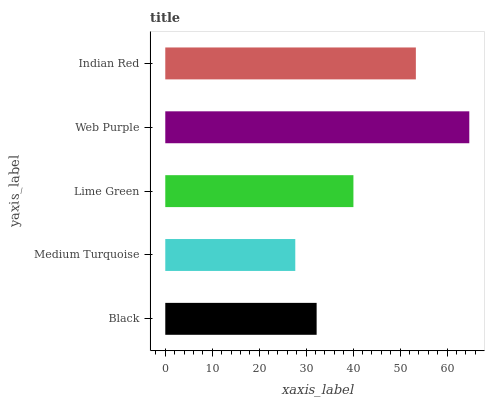Is Medium Turquoise the minimum?
Answer yes or no. Yes. Is Web Purple the maximum?
Answer yes or no. Yes. Is Lime Green the minimum?
Answer yes or no. No. Is Lime Green the maximum?
Answer yes or no. No. Is Lime Green greater than Medium Turquoise?
Answer yes or no. Yes. Is Medium Turquoise less than Lime Green?
Answer yes or no. Yes. Is Medium Turquoise greater than Lime Green?
Answer yes or no. No. Is Lime Green less than Medium Turquoise?
Answer yes or no. No. Is Lime Green the high median?
Answer yes or no. Yes. Is Lime Green the low median?
Answer yes or no. Yes. Is Medium Turquoise the high median?
Answer yes or no. No. Is Medium Turquoise the low median?
Answer yes or no. No. 